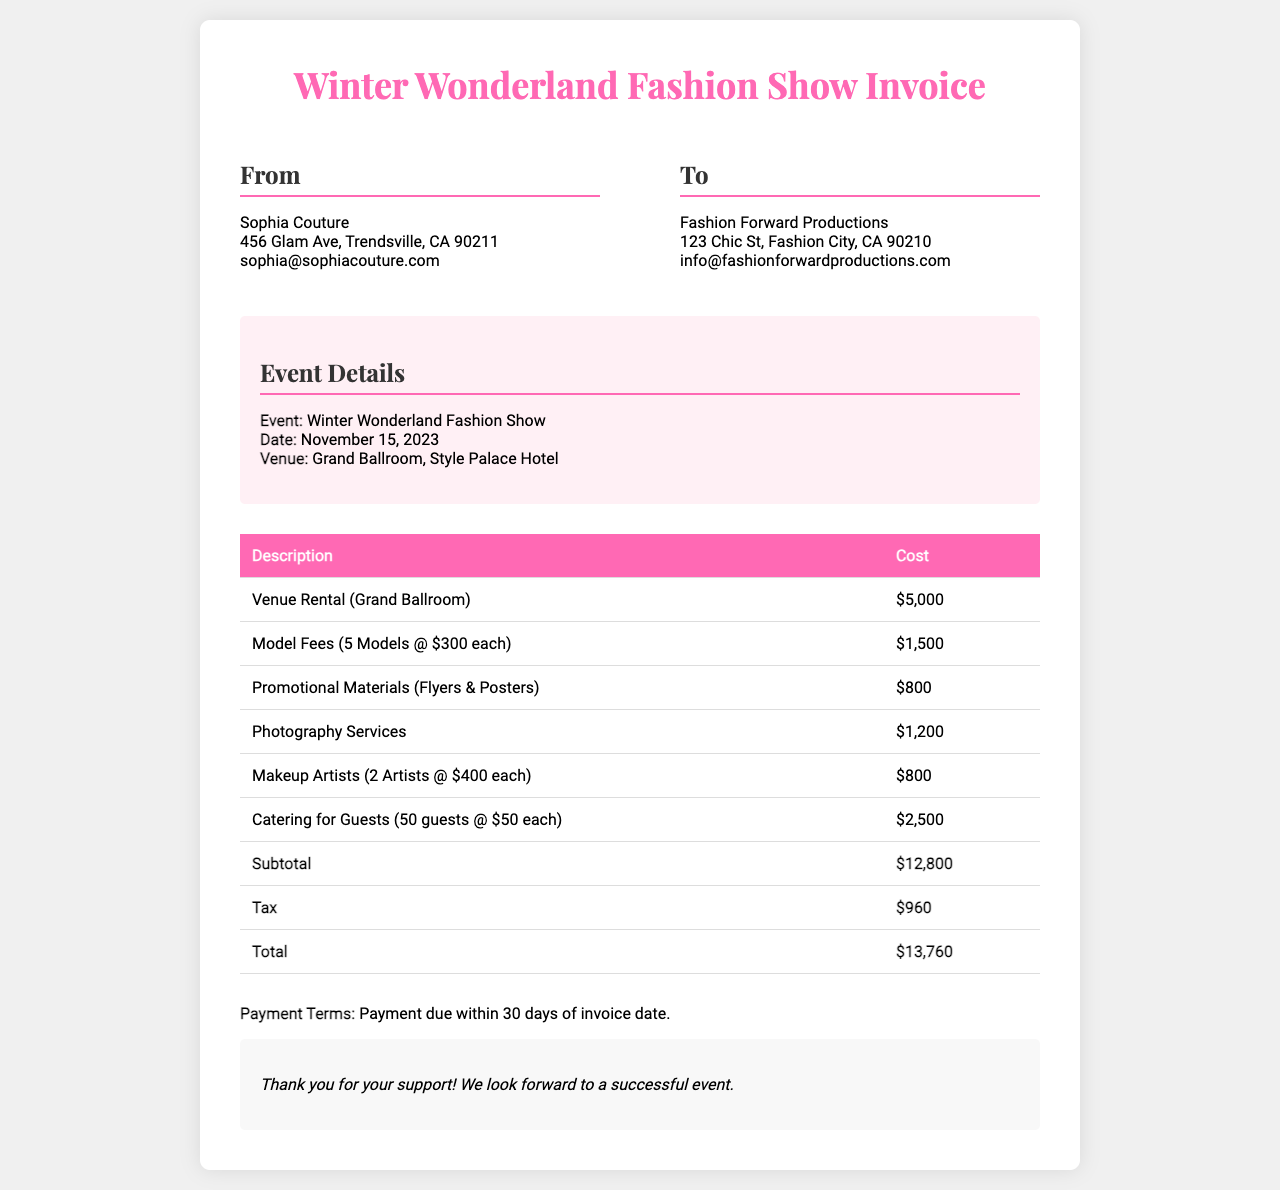What is the total cost of the event? The total cost is listed as the final amount in the invoice table, which includes all expenses.
Answer: $13,760 What is the cost of the venue rental? The cost for the venue rental is specified in the table under 'Venue Rental (Grand Ballroom)'.
Answer: $5,000 How many models were hired for the fashion show? The invoice mentions that 5 models were hired at a specified fee each.
Answer: 5 Models What service is provided by 2 artists at a total of 800 dollars? The document states that makeup artists were hired, and their total cost is given.
Answer: Makeup Artists What is the date of the Winter Wonderland Fashion Show? The date is provided in the event details section of the invoice.
Answer: November 15, 2023 What is the subtotal before tax? The subtotal is the sum of all listed costs before tax is applied, as shown in the invoice.
Answer: $12,800 Who is the sender of the invoice? The sender's name and details are clearly displayed at the top of the invoice, under the "From" section.
Answer: Sophia Couture What types of promotional materials were included in the costs? The invoice specifies the types of materials included in the promotional costs.
Answer: Flyers & Posters What payment terms are outlined in the invoice? The payment terms detail how soon payment should be made after receiving the invoice, which is summed up in a brief statement.
Answer: Payment due within 30 days of invoice date 